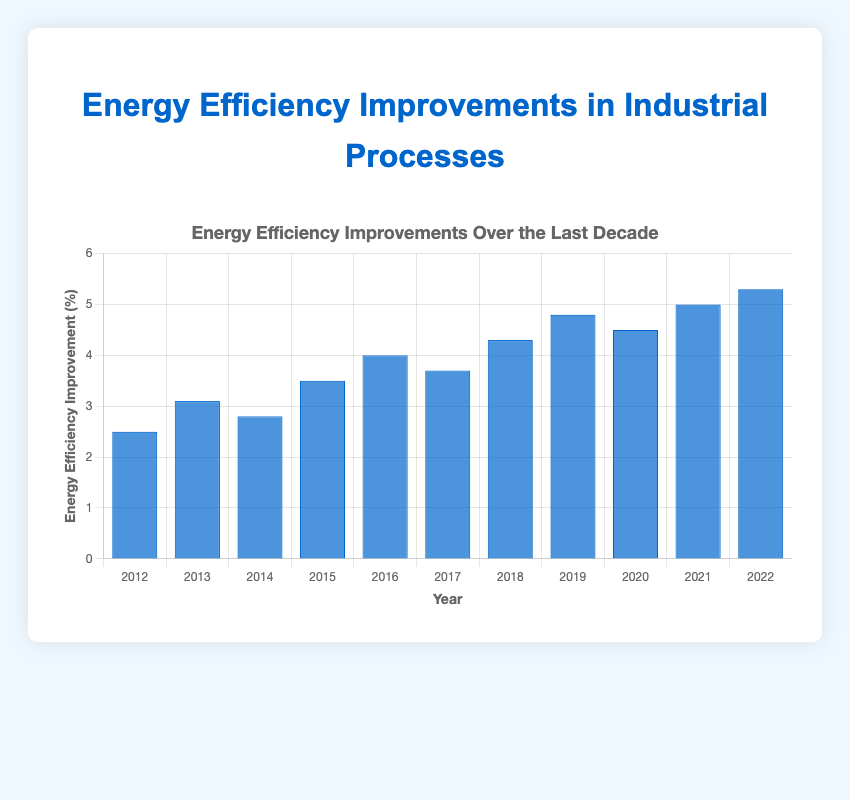Which year had the highest energy efficiency improvement? To find the year with the highest energy efficiency improvement, look for the tallest bar. The tallest bar is for the year 2022 with a 5.3% improvement.
Answer: 2022 What is the total energy efficiency improvement over the last decade (2012-2022)? Add the improvements for each year: 2.5 + 3.1 + 2.8 + 3.5 + 4.0 + 3.7 + 4.3 + 4.8 + 4.5 + 5.0 + 5.3 = 43.5%
Answer: 43.5% Which year saw a decrease in energy efficiency improvement compared to the previous year? Look for bars that are shorter than their predecessor. The year 2017 had a decrease compared to 2016, and the year 2020 had a decrease compared to 2019.
Answer: 2017, 2020 What is the average annual energy efficiency improvement over the given period? Add all the annual improvements and divide by the number of years: (2.5 + 3.1 + 2.8 + 3.5 + 4.0 + 3.7 + 4.3 + 4.8 + 4.5 + 5.0 + 5.3) / 11 ≈ 3.95%
Answer: 3.95% Between which two consecutive years was the increase in energy efficiency improvement the greatest? Calculate the differences between consecutive years and identify the maximum: 2013-2012 = 0.6, 2014-2013 = -0.3, 2015-2014 = 0.7, 2016-2015 = 0.5, 2017-2016 = -0.3, 2018-2017 = 0.6, 2019-2018 = 0.5, 2020-2019 = -0.3, 2021-2020 = 0.5, 2022-2021 = 0.3. The greatest increase was from 2014 to 2015, which is 0.7.
Answer: 2014 to 2015 How does the energy efficiency improvement in 2020 compare to that in 2018? Compare the heights of 2020 and 2018 bars. In 2020, it was 4.5%, whereas in 2018, it was 4.3%. Thus, 2020's improvement is higher by 0.2%.
Answer: 2020 is higher by 0.2% What is the median energy efficiency improvement between 2012 and 2022? List the values in ascending order and find the middle one: 2.5, 2.8, 3.1, 3.5, 3.7, 4.0, 4.3, 4.5, 4.8, 5.0, 5.3. The median value is 4.0%.
Answer: 4.0% Which year saw the first instance of an energy efficiency improvement over 4%? Identify the first bar that reaches above the value of 4%. The year 2016 saw an improvement of 4.0%.
Answer: 2016 How many years had an energy efficiency improvement greater than 4%? Count the bars with values higher than 4%. These years are 2016, 2018, 2019, 2020, 2021, and 2022, making a total of 6 years.
Answer: 6 